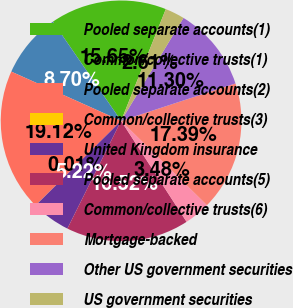<chart> <loc_0><loc_0><loc_500><loc_500><pie_chart><fcel>Pooled separate accounts(1)<fcel>Common/collective trusts(1)<fcel>Pooled separate accounts(2)<fcel>Common/collective trusts(3)<fcel>United Kingdom insurance<fcel>Pooled separate accounts(5)<fcel>Common/collective trusts(6)<fcel>Mortgage-backed<fcel>Other US government securities<fcel>US government securities<nl><fcel>15.65%<fcel>8.7%<fcel>19.12%<fcel>0.01%<fcel>5.22%<fcel>16.52%<fcel>3.48%<fcel>17.39%<fcel>11.3%<fcel>2.61%<nl></chart> 